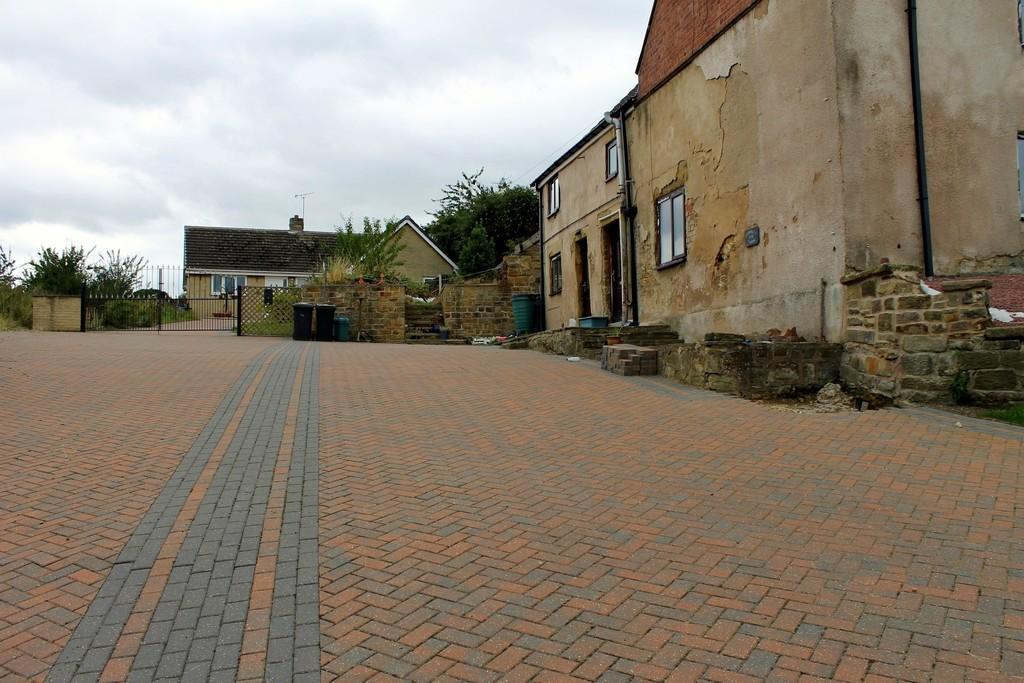Please provide a concise description of this image. In this image there is a pavement in the middle. There is a building on the right side. At the top there is the sky. In the background there is a gate, behind the gate there is a house. On the left side there are plants. On the right side there is a wall. 